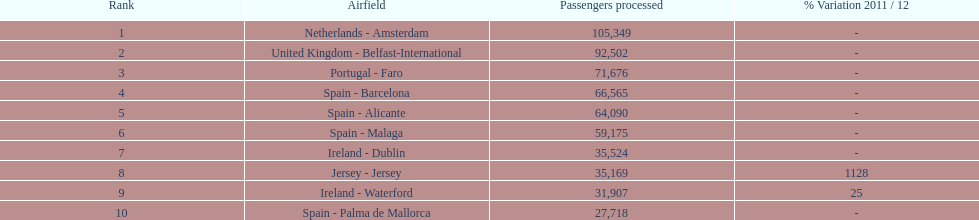Name all the london southend airports that did not list a change in 2001/12. Netherlands - Amsterdam, United Kingdom - Belfast-International, Portugal - Faro, Spain - Barcelona, Spain - Alicante, Spain - Malaga, Ireland - Dublin, Spain - Palma de Mallorca. What unchanged percentage airports from 2011/12 handled less then 50,000 passengers? Ireland - Dublin, Spain - Palma de Mallorca. What unchanged percentage airport from 2011/12 handled less then 50,000 passengers is the closest to the equator? Spain - Palma de Mallorca. 